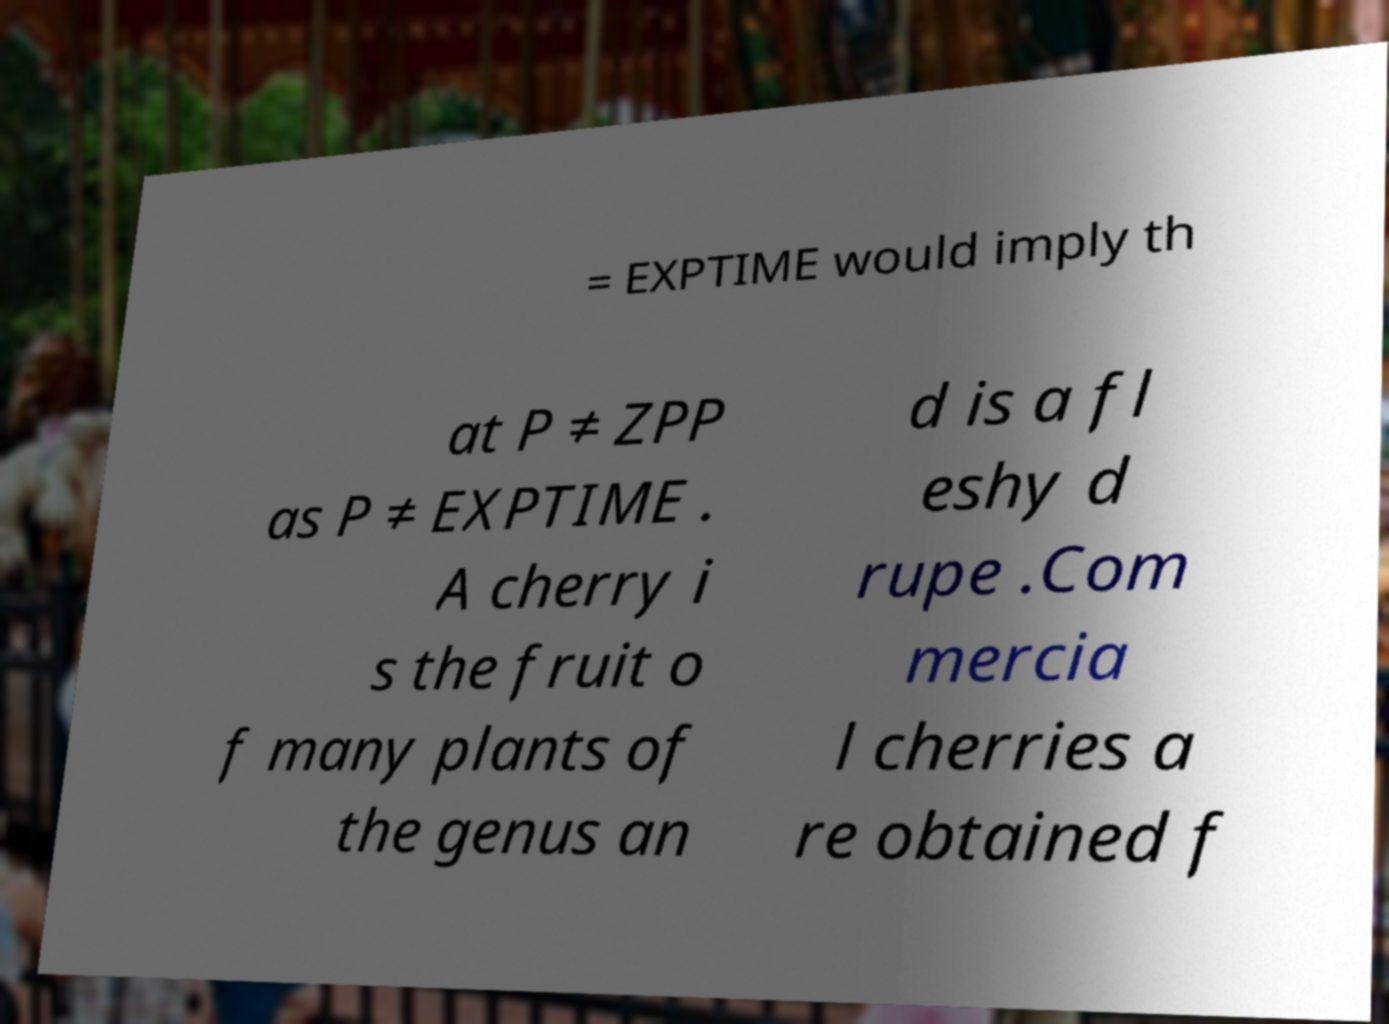I need the written content from this picture converted into text. Can you do that? = EXPTIME would imply th at P ≠ ZPP as P ≠ EXPTIME . A cherry i s the fruit o f many plants of the genus an d is a fl eshy d rupe .Com mercia l cherries a re obtained f 